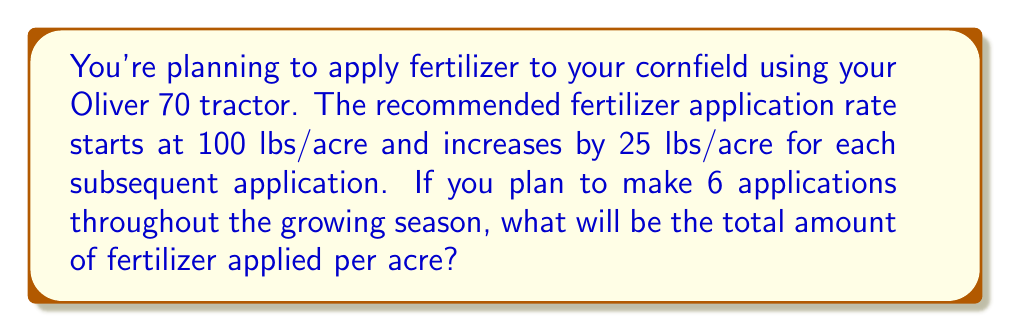Solve this math problem. Let's approach this step-by-step using arithmetic sequences:

1) We have an arithmetic sequence where:
   - First term, $a_1 = 100$ lbs/acre
   - Common difference, $d = 25$ lbs/acre
   - Number of terms, $n = 6$

2) The sequence of application rates will be:
   100, 125, 150, 175, 200, 225 lbs/acre

3) To find the total amount, we need to find the sum of this arithmetic sequence.
   We can use the formula for the sum of an arithmetic sequence:

   $S_n = \frac{n}{2}(a_1 + a_n)$

   Where $a_n$ is the last term, which we can calculate using:
   $a_n = a_1 + (n-1)d$

4) Let's find $a_n$:
   $a_6 = 100 + (6-1)25 = 100 + 125 = 225$

5) Now we can calculate the sum:

   $S_6 = \frac{6}{2}(100 + 225) = 3(325) = 975$

Therefore, the total amount of fertilizer applied per acre over the 6 applications will be 975 lbs/acre.
Answer: 975 lbs/acre 